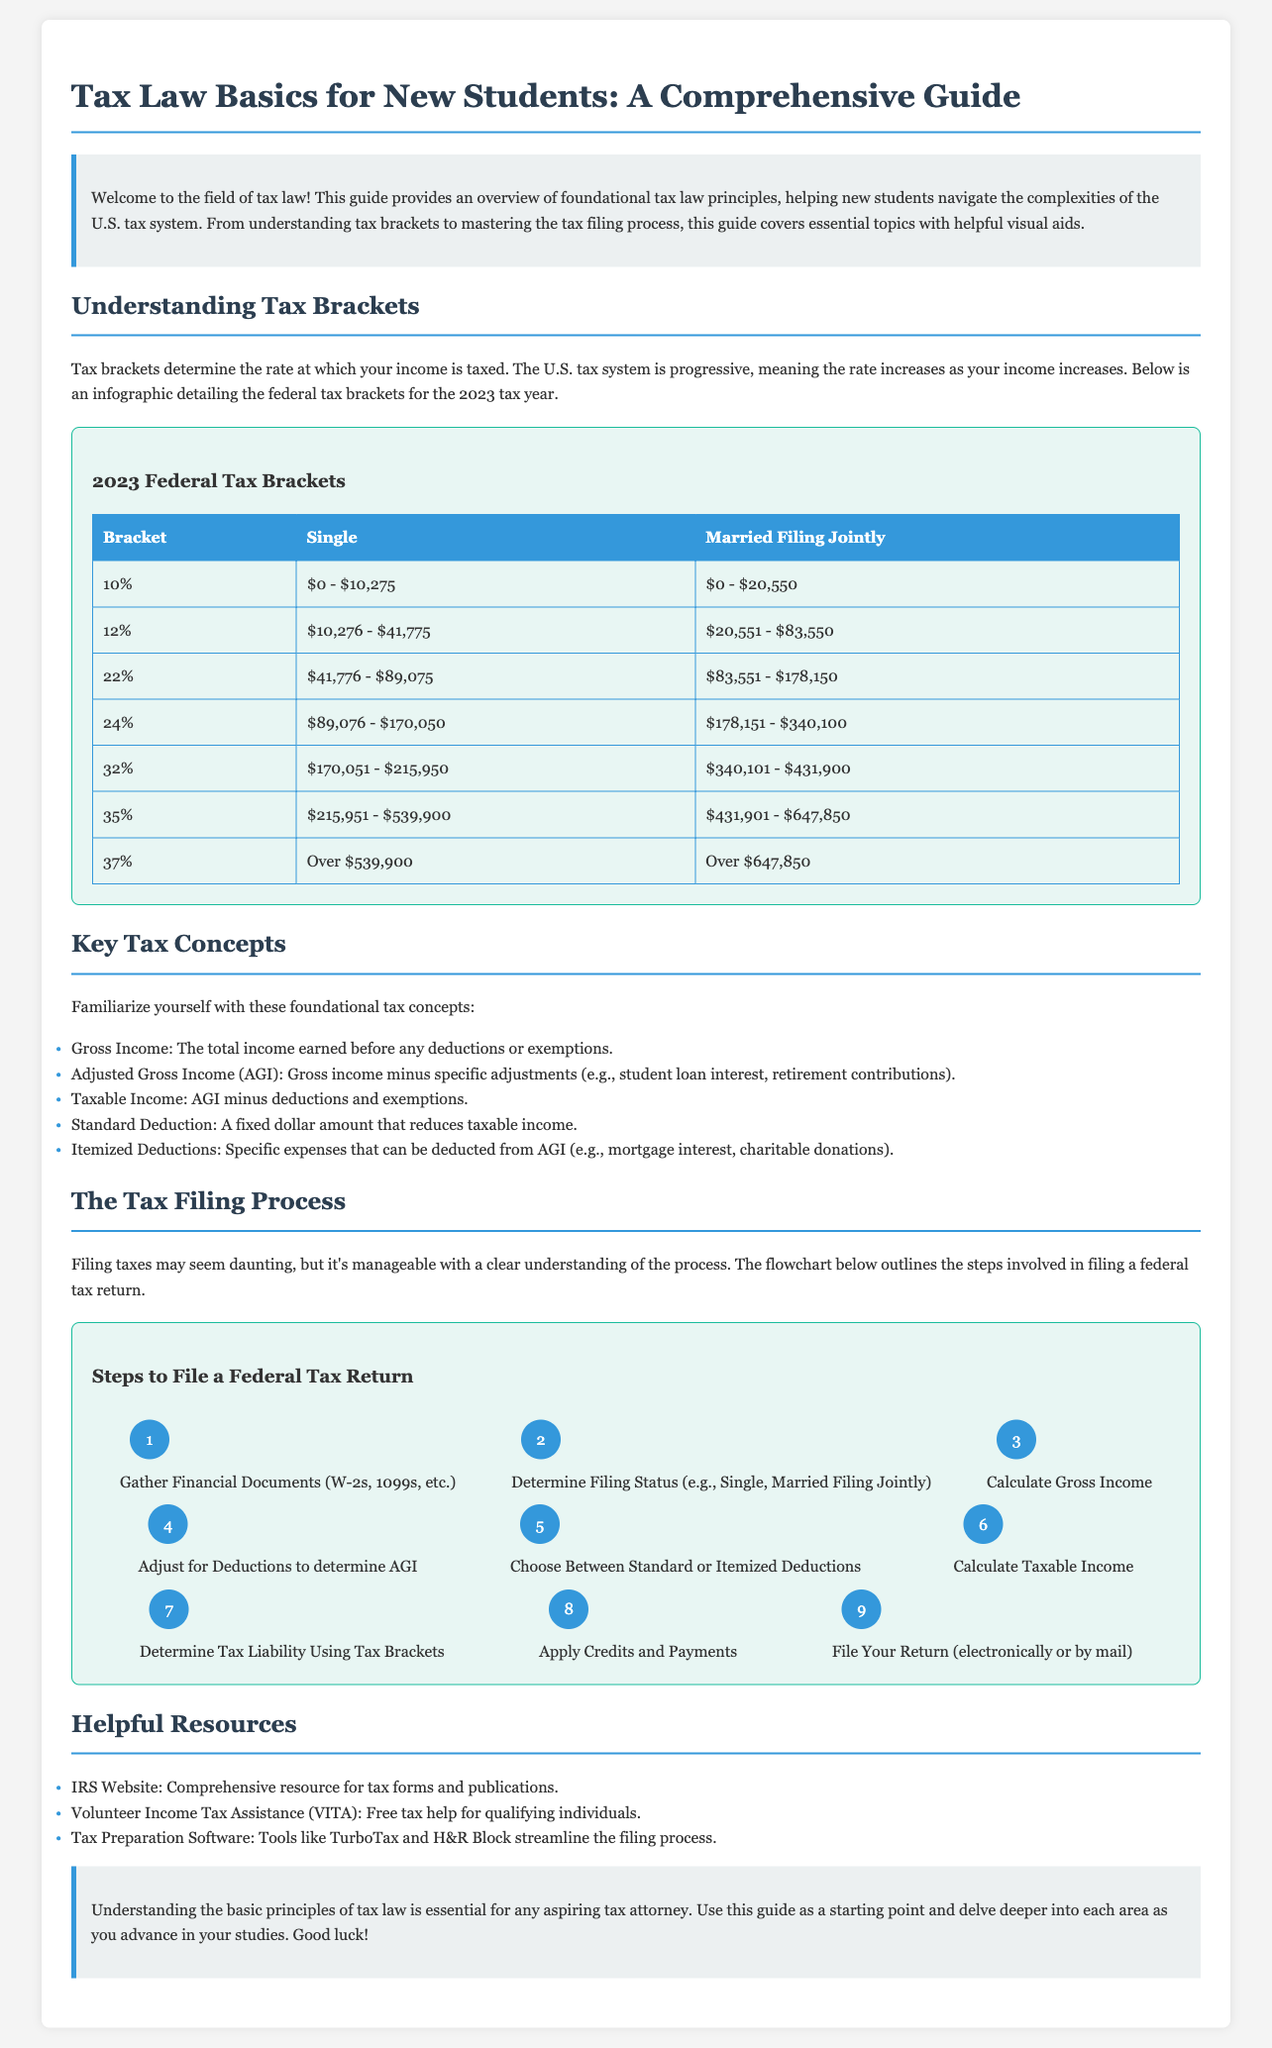What is the title of the guide? The title of the guide is clearly stated at the beginning of the document.
Answer: Tax Law Basics for New Students: A Comprehensive Guide What are the federal tax brackets for the 2023 tax year? The document contains a table specifically detailing the federal tax brackets for 2023.
Answer: 10%, 12%, 22%, 24%, 32%, 35%, 37% What percentage is the standard deduction for a single filer in 2023? The guide mentions the standard deduction as a key tax concept but does not specify the amount.
Answer: Not specified What do you need to file before filing your tax return? The flowchart includes a step that identifies necessary documentation needed for tax filing.
Answer: Gather Financial Documents (W-2s, 1099s, etc.) How many steps are in the tax filing process flowchart? The flowchart outlines the steps involved in filing a federal tax return.
Answer: 9 What is the purpose of the infographic included in the guide? The infographic contains specific visual information regarding a tax concept outlined in the guide.
Answer: To detail the federal tax brackets Which resource is mentioned for free tax help? The guide lists resources for assistance with tax filing, including one that offers free help.
Answer: Volunteer Income Tax Assistance (VITA) What is the main objective of the guide? The introduction provides a clear statement about the aim of the guide for new law students.
Answer: To help new students navigate the complexities of the U.S. tax system What should you determine when filing a tax return? The flowchart includes a key initial decision point in the filing process.
Answer: Determine Filing Status (e.g., Single, Married Filing Jointly) 